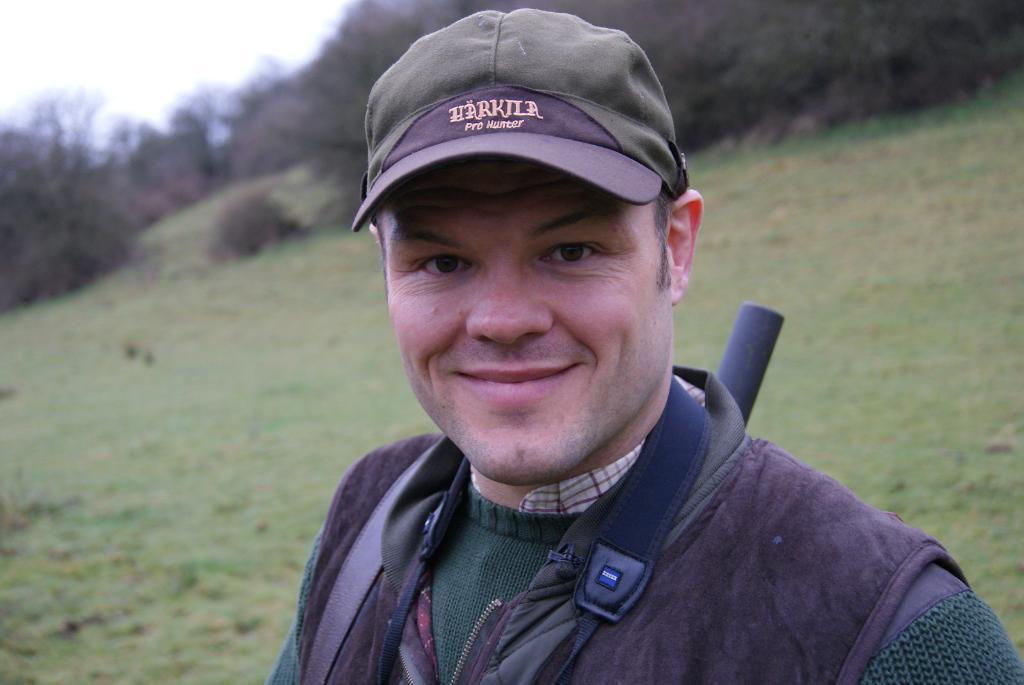Describe this image in one or two sentences. In the image there is a man in sweatshirt and cap standing in the front and behind the land is covered with grass and trees. 